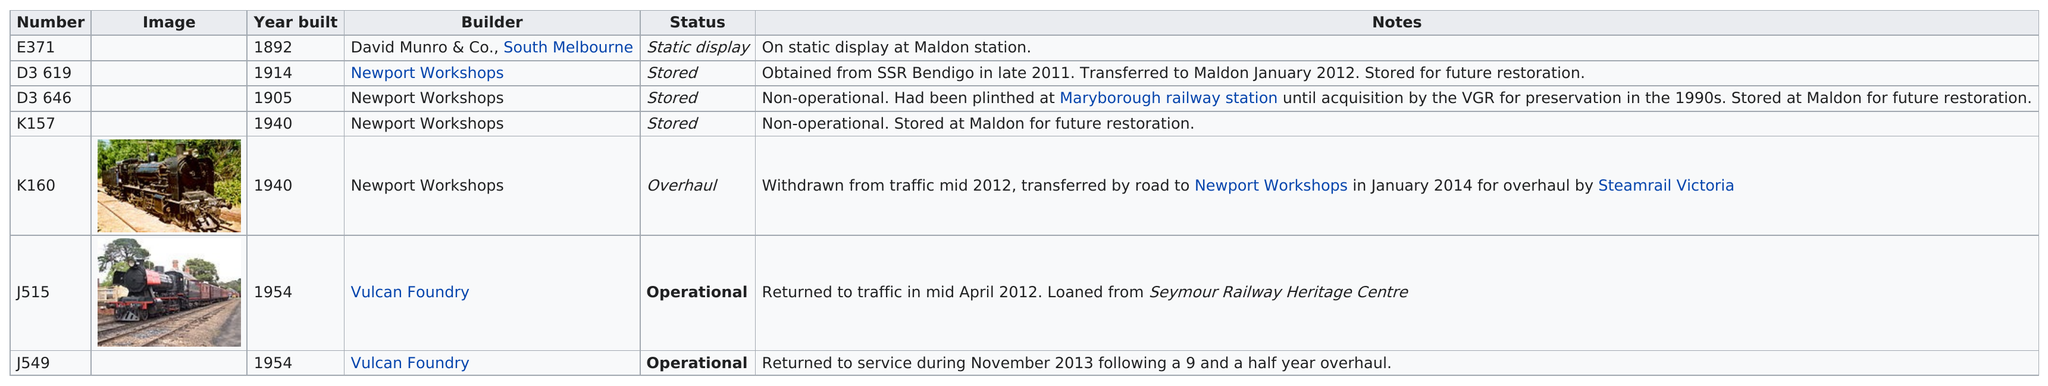Give some essential details in this illustration. The only trains currently in operation are J515 and J549. Thirty-three locomotives, built prior to 1940, were identified in the records. 